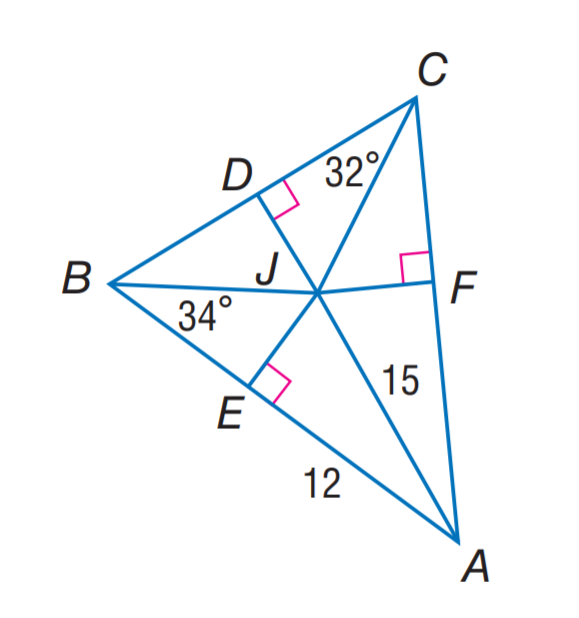Answer the mathemtical geometry problem and directly provide the correct option letter.
Question: J is the incenter of \angle A B C. Find m \angle J A C.
Choices: A: 15 B: 24 C: 32 D: 34 B 